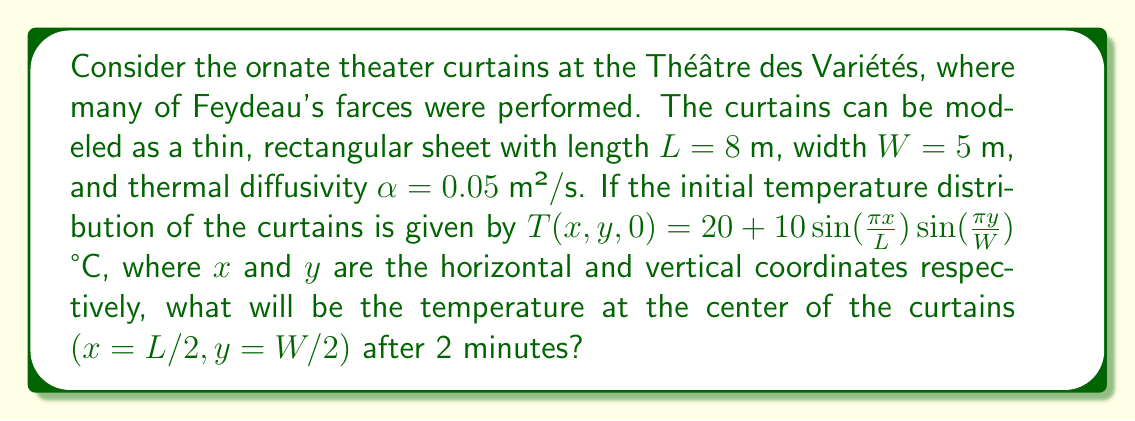Provide a solution to this math problem. To solve this problem, we need to use the 2D heat equation:

$$\frac{\partial T}{\partial t} = \alpha(\frac{\partial^2 T}{\partial x^2} + \frac{\partial^2 T}{\partial y^2})$$

The solution for this equation with the given initial condition can be expressed as:

$$T(x,y,t) = 20 + 10\sin(\frac{\pi x}{L})\sin(\frac{\pi y}{W})e^{-\alpha t(\frac{\pi^2}{L^2} + \frac{\pi^2}{W^2})}$$

Let's solve this step by step:

1) First, we need to calculate the exponent:
   $-\alpha t(\frac{\pi^2}{L^2} + \frac{\pi^2}{W^2})$
   
   $\alpha = 0.05$ m²/s
   $t = 2$ minutes = 120 seconds
   $L = 8$ m
   $W = 5$ m

   $-0.05 \cdot 120 \cdot (\frac{\pi^2}{8^2} + \frac{\pi^2}{5^2})$
   $= -6 \cdot (\frac{\pi^2}{64} + \frac{\pi^2}{25})$
   $= -6 \cdot (0.1541 + 0.3948)$
   $= -6 \cdot 0.5489$
   $= -3.2934$

2) Now, let's calculate $e^{-3.2934} \approx 0.0371$

3) At the center of the curtains, $x = L/2 = 4$ m and $y = W/2 = 2.5$ m

4) Substituting these values into our equation:

   $T(4, 2.5, 120) = 20 + 10\sin(\frac{\pi \cdot 4}{8})\sin(\frac{\pi \cdot 2.5}{5}) \cdot 0.0371$
   
   $= 20 + 10\sin(\frac{\pi}{2})\sin(\frac{\pi}{2}) \cdot 0.0371$
   
   $= 20 + 10 \cdot 1 \cdot 1 \cdot 0.0371$
   
   $= 20 + 0.371$
   
   $= 20.371$ °C

Therefore, the temperature at the center of the curtains after 2 minutes will be approximately 20.371 °C.
Answer: 20.371 °C 